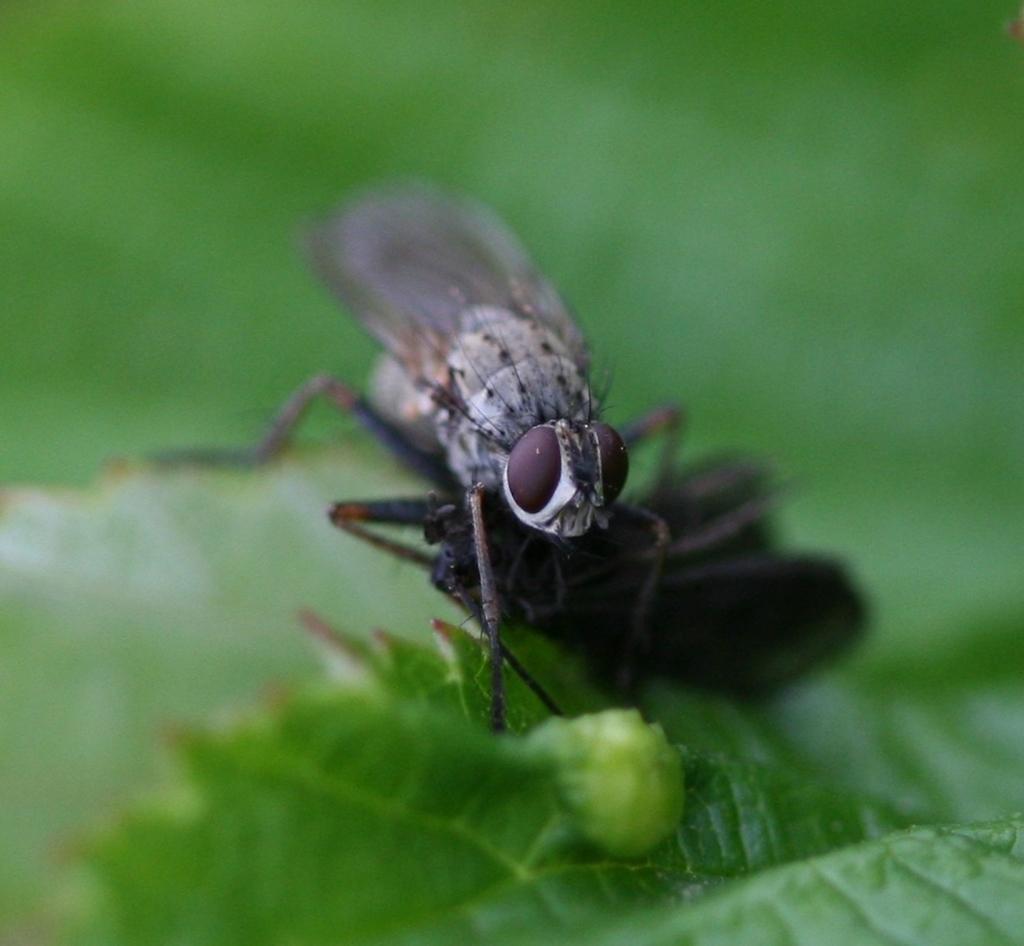How would you summarize this image in a sentence or two? In this picture we can see a housefly and a black thing on the leaf. Behind the housefly there is a blurred background. 